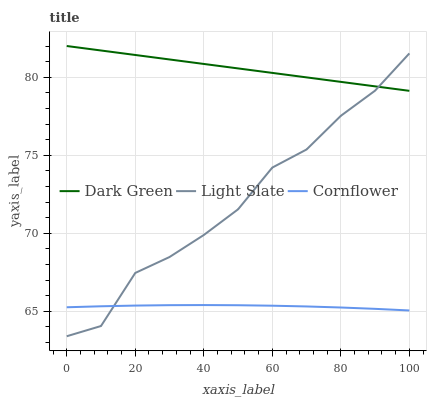Does Cornflower have the minimum area under the curve?
Answer yes or no. Yes. Does Dark Green have the maximum area under the curve?
Answer yes or no. Yes. Does Dark Green have the minimum area under the curve?
Answer yes or no. No. Does Cornflower have the maximum area under the curve?
Answer yes or no. No. Is Dark Green the smoothest?
Answer yes or no. Yes. Is Light Slate the roughest?
Answer yes or no. Yes. Is Cornflower the smoothest?
Answer yes or no. No. Is Cornflower the roughest?
Answer yes or no. No. Does Light Slate have the lowest value?
Answer yes or no. Yes. Does Cornflower have the lowest value?
Answer yes or no. No. Does Dark Green have the highest value?
Answer yes or no. Yes. Does Cornflower have the highest value?
Answer yes or no. No. Is Cornflower less than Dark Green?
Answer yes or no. Yes. Is Dark Green greater than Cornflower?
Answer yes or no. Yes. Does Dark Green intersect Light Slate?
Answer yes or no. Yes. Is Dark Green less than Light Slate?
Answer yes or no. No. Is Dark Green greater than Light Slate?
Answer yes or no. No. Does Cornflower intersect Dark Green?
Answer yes or no. No. 